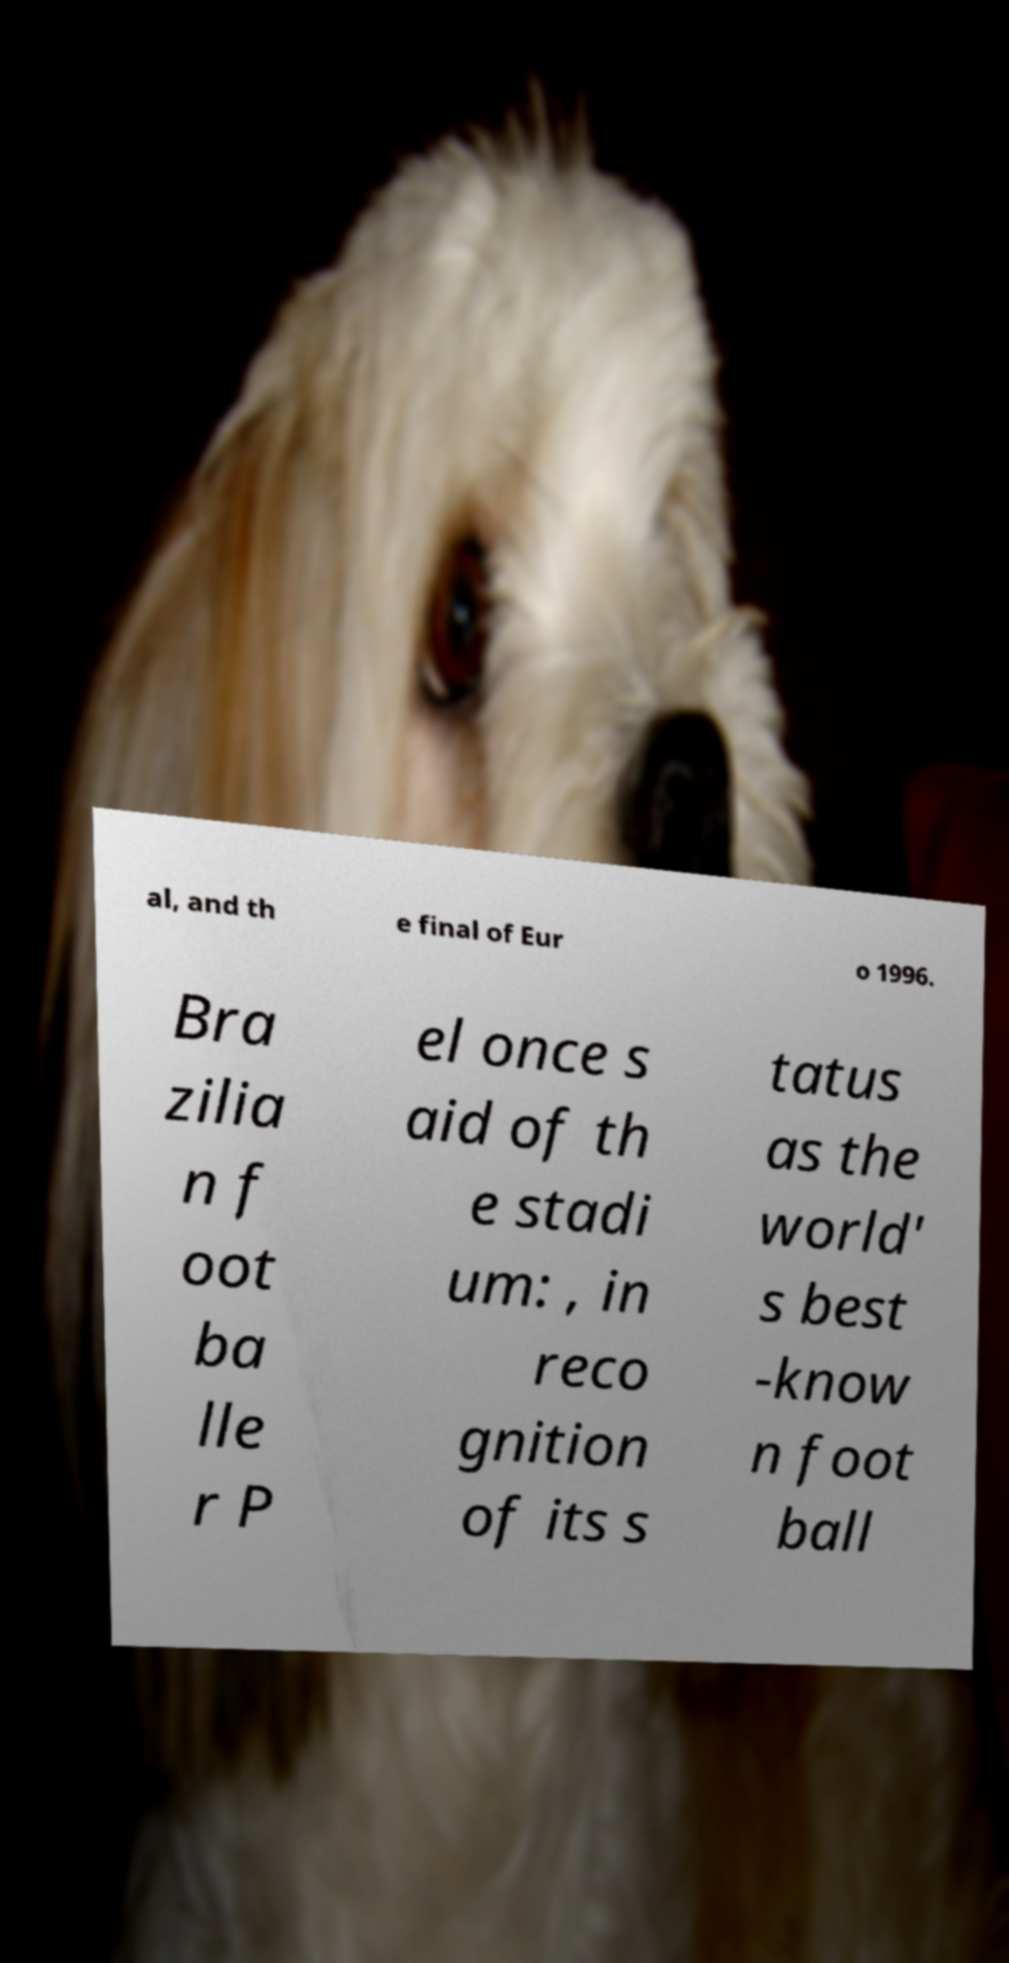Please identify and transcribe the text found in this image. al, and th e final of Eur o 1996. Bra zilia n f oot ba lle r P el once s aid of th e stadi um: , in reco gnition of its s tatus as the world' s best -know n foot ball 